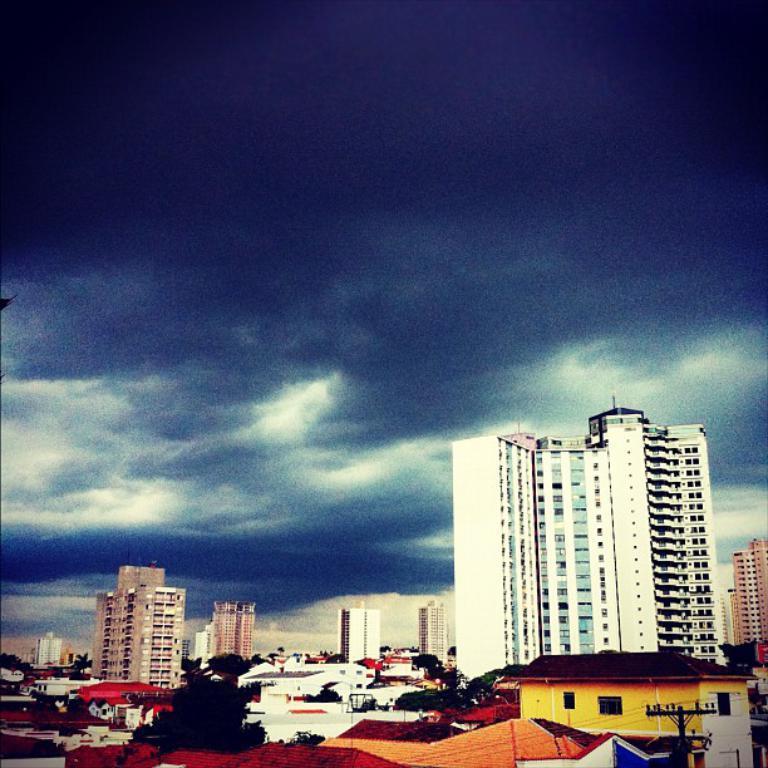Describe this image in one or two sentences. In this picture we can see buildings, trees, electric pole with cables, houses and a cloudy sky. 